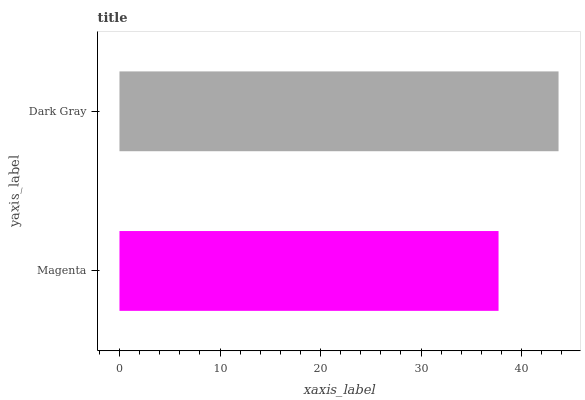Is Magenta the minimum?
Answer yes or no. Yes. Is Dark Gray the maximum?
Answer yes or no. Yes. Is Dark Gray the minimum?
Answer yes or no. No. Is Dark Gray greater than Magenta?
Answer yes or no. Yes. Is Magenta less than Dark Gray?
Answer yes or no. Yes. Is Magenta greater than Dark Gray?
Answer yes or no. No. Is Dark Gray less than Magenta?
Answer yes or no. No. Is Dark Gray the high median?
Answer yes or no. Yes. Is Magenta the low median?
Answer yes or no. Yes. Is Magenta the high median?
Answer yes or no. No. Is Dark Gray the low median?
Answer yes or no. No. 